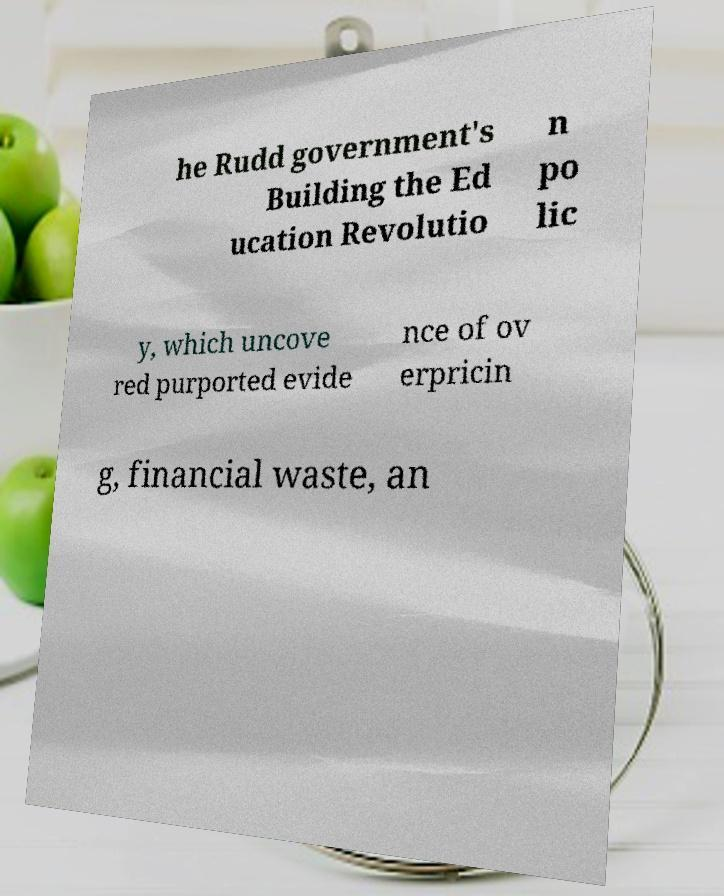Please identify and transcribe the text found in this image. he Rudd government's Building the Ed ucation Revolutio n po lic y, which uncove red purported evide nce of ov erpricin g, financial waste, an 